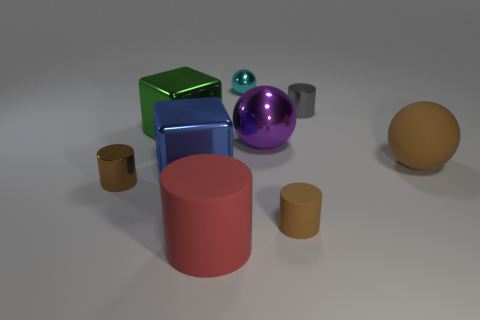Subtract all big red matte cylinders. How many cylinders are left? 3 Subtract all blocks. How many objects are left? 7 Subtract 3 cylinders. How many cylinders are left? 1 Add 1 cylinders. How many cylinders are left? 5 Add 7 big cylinders. How many big cylinders exist? 8 Subtract all red cylinders. How many cylinders are left? 3 Subtract 0 gray blocks. How many objects are left? 9 Subtract all blue cylinders. Subtract all cyan balls. How many cylinders are left? 4 Subtract all brown cubes. How many gray balls are left? 0 Subtract all blue metallic objects. Subtract all large brown objects. How many objects are left? 7 